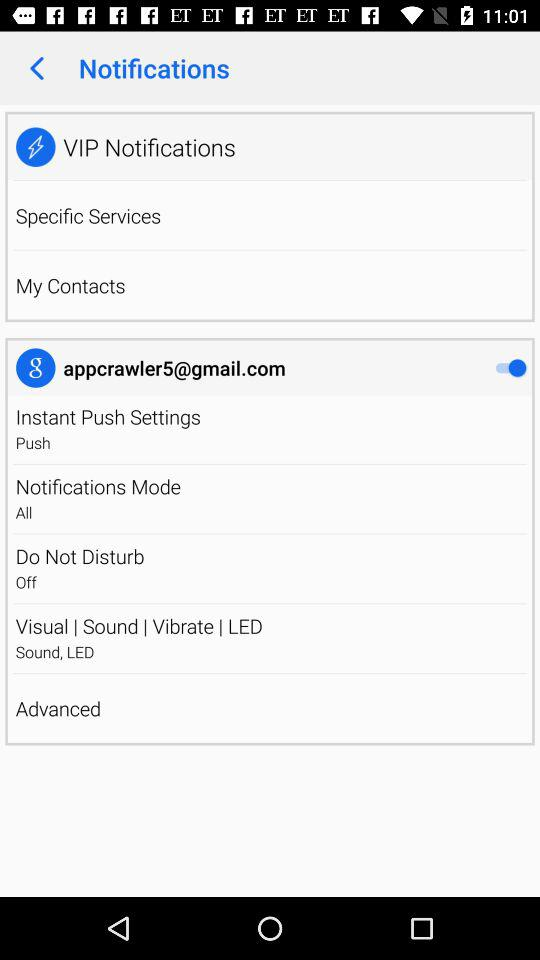What is the status of "Do Not Disturb"? The status is "off". 